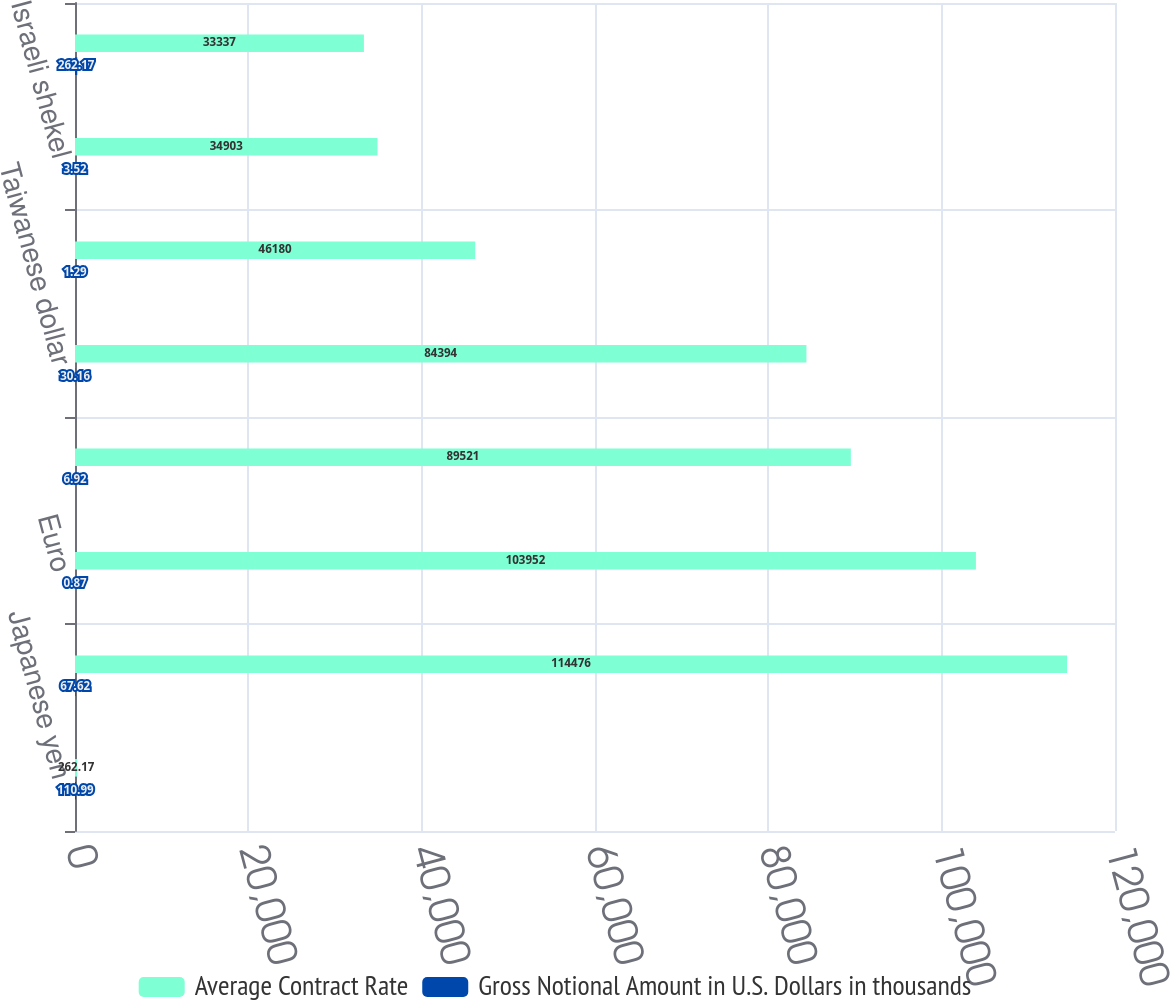Convert chart to OTSL. <chart><loc_0><loc_0><loc_500><loc_500><stacked_bar_chart><ecel><fcel>Japanese yen<fcel>Indian Rupee<fcel>Euro<fcel>Chinese renminbi<fcel>Taiwanese dollar<fcel>Canadian dollar<fcel>Israeli shekel<fcel>Hungarian forint<nl><fcel>Average Contract Rate<fcel>262.17<fcel>114476<fcel>103952<fcel>89521<fcel>84394<fcel>46180<fcel>34903<fcel>33337<nl><fcel>Gross Notional Amount in U.S. Dollars in thousands<fcel>110.99<fcel>67.62<fcel>0.87<fcel>6.92<fcel>30.16<fcel>1.29<fcel>3.52<fcel>262.17<nl></chart> 